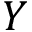Convert formula to latex. <formula><loc_0><loc_0><loc_500><loc_500>Y</formula> 